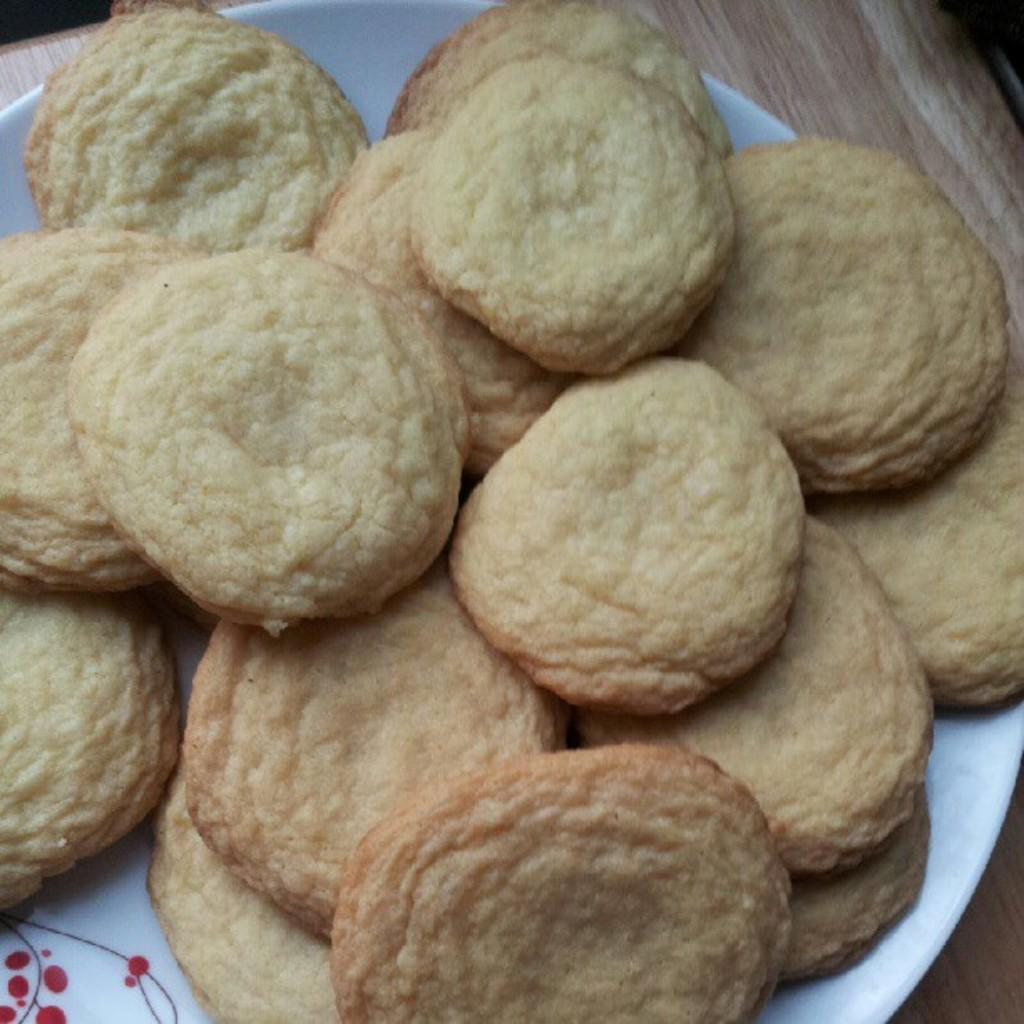What type of food can be seen on the plate in the image? There are cookies on a plate in the image. Where is the plate with cookies located? The plate is placed on a table. What type of destruction can be seen happening to the cookies in the image? There is no destruction happening to the cookies in the image; they are simply sitting on the plate. 